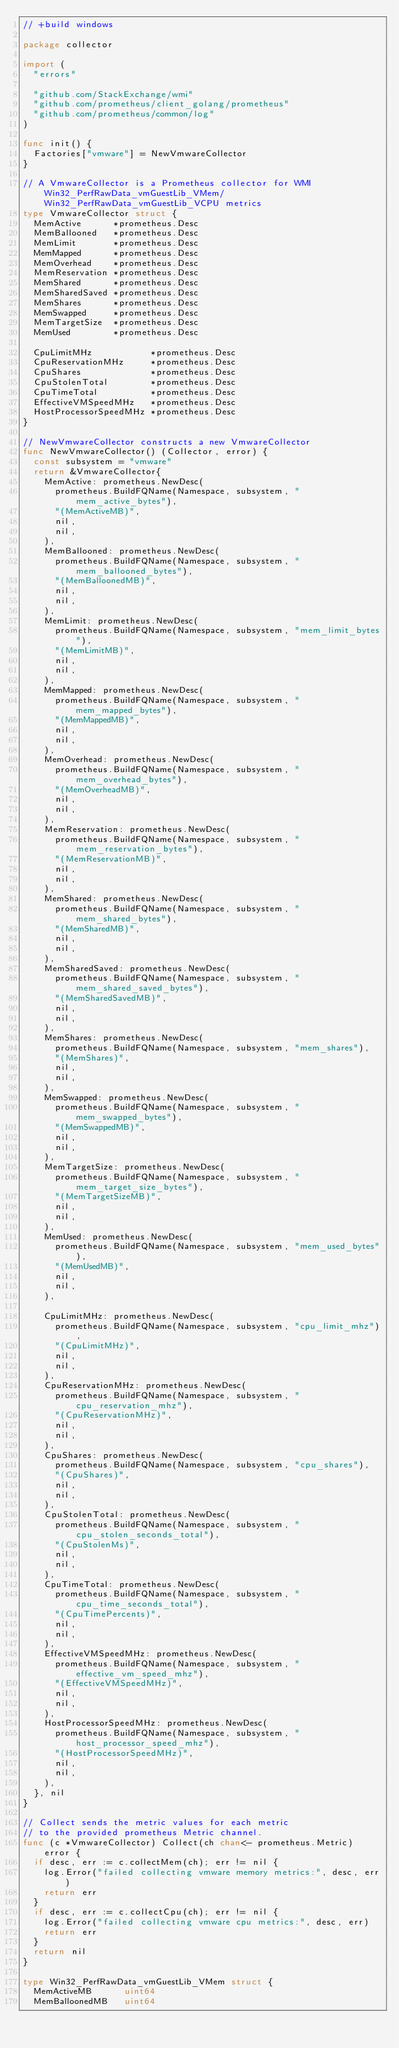<code> <loc_0><loc_0><loc_500><loc_500><_Go_>// +build windows

package collector

import (
	"errors"

	"github.com/StackExchange/wmi"
	"github.com/prometheus/client_golang/prometheus"
	"github.com/prometheus/common/log"
)

func init() {
	Factories["vmware"] = NewVmwareCollector
}

// A VmwareCollector is a Prometheus collector for WMI Win32_PerfRawData_vmGuestLib_VMem/Win32_PerfRawData_vmGuestLib_VCPU metrics
type VmwareCollector struct {
	MemActive      *prometheus.Desc
	MemBallooned   *prometheus.Desc
	MemLimit       *prometheus.Desc
	MemMapped      *prometheus.Desc
	MemOverhead    *prometheus.Desc
	MemReservation *prometheus.Desc
	MemShared      *prometheus.Desc
	MemSharedSaved *prometheus.Desc
	MemShares      *prometheus.Desc
	MemSwapped     *prometheus.Desc
	MemTargetSize  *prometheus.Desc
	MemUsed        *prometheus.Desc

	CpuLimitMHz           *prometheus.Desc
	CpuReservationMHz     *prometheus.Desc
	CpuShares             *prometheus.Desc
	CpuStolenTotal        *prometheus.Desc
	CpuTimeTotal          *prometheus.Desc
	EffectiveVMSpeedMHz   *prometheus.Desc
	HostProcessorSpeedMHz *prometheus.Desc
}

// NewVmwareCollector constructs a new VmwareCollector
func NewVmwareCollector() (Collector, error) {
	const subsystem = "vmware"
	return &VmwareCollector{
		MemActive: prometheus.NewDesc(
			prometheus.BuildFQName(Namespace, subsystem, "mem_active_bytes"),
			"(MemActiveMB)",
			nil,
			nil,
		),
		MemBallooned: prometheus.NewDesc(
			prometheus.BuildFQName(Namespace, subsystem, "mem_ballooned_bytes"),
			"(MemBalloonedMB)",
			nil,
			nil,
		),
		MemLimit: prometheus.NewDesc(
			prometheus.BuildFQName(Namespace, subsystem, "mem_limit_bytes"),
			"(MemLimitMB)",
			nil,
			nil,
		),
		MemMapped: prometheus.NewDesc(
			prometheus.BuildFQName(Namespace, subsystem, "mem_mapped_bytes"),
			"(MemMappedMB)",
			nil,
			nil,
		),
		MemOverhead: prometheus.NewDesc(
			prometheus.BuildFQName(Namespace, subsystem, "mem_overhead_bytes"),
			"(MemOverheadMB)",
			nil,
			nil,
		),
		MemReservation: prometheus.NewDesc(
			prometheus.BuildFQName(Namespace, subsystem, "mem_reservation_bytes"),
			"(MemReservationMB)",
			nil,
			nil,
		),
		MemShared: prometheus.NewDesc(
			prometheus.BuildFQName(Namespace, subsystem, "mem_shared_bytes"),
			"(MemSharedMB)",
			nil,
			nil,
		),
		MemSharedSaved: prometheus.NewDesc(
			prometheus.BuildFQName(Namespace, subsystem, "mem_shared_saved_bytes"),
			"(MemSharedSavedMB)",
			nil,
			nil,
		),
		MemShares: prometheus.NewDesc(
			prometheus.BuildFQName(Namespace, subsystem, "mem_shares"),
			"(MemShares)",
			nil,
			nil,
		),
		MemSwapped: prometheus.NewDesc(
			prometheus.BuildFQName(Namespace, subsystem, "mem_swapped_bytes"),
			"(MemSwappedMB)",
			nil,
			nil,
		),
		MemTargetSize: prometheus.NewDesc(
			prometheus.BuildFQName(Namespace, subsystem, "mem_target_size_bytes"),
			"(MemTargetSizeMB)",
			nil,
			nil,
		),
		MemUsed: prometheus.NewDesc(
			prometheus.BuildFQName(Namespace, subsystem, "mem_used_bytes"),
			"(MemUsedMB)",
			nil,
			nil,
		),

		CpuLimitMHz: prometheus.NewDesc(
			prometheus.BuildFQName(Namespace, subsystem, "cpu_limit_mhz"),
			"(CpuLimitMHz)",
			nil,
			nil,
		),
		CpuReservationMHz: prometheus.NewDesc(
			prometheus.BuildFQName(Namespace, subsystem, "cpu_reservation_mhz"),
			"(CpuReservationMHz)",
			nil,
			nil,
		),
		CpuShares: prometheus.NewDesc(
			prometheus.BuildFQName(Namespace, subsystem, "cpu_shares"),
			"(CpuShares)",
			nil,
			nil,
		),
		CpuStolenTotal: prometheus.NewDesc(
			prometheus.BuildFQName(Namespace, subsystem, "cpu_stolen_seconds_total"),
			"(CpuStolenMs)",
			nil,
			nil,
		),
		CpuTimeTotal: prometheus.NewDesc(
			prometheus.BuildFQName(Namespace, subsystem, "cpu_time_seconds_total"),
			"(CpuTimePercents)",
			nil,
			nil,
		),
		EffectiveVMSpeedMHz: prometheus.NewDesc(
			prometheus.BuildFQName(Namespace, subsystem, "effective_vm_speed_mhz"),
			"(EffectiveVMSpeedMHz)",
			nil,
			nil,
		),
		HostProcessorSpeedMHz: prometheus.NewDesc(
			prometheus.BuildFQName(Namespace, subsystem, "host_processor_speed_mhz"),
			"(HostProcessorSpeedMHz)",
			nil,
			nil,
		),
	}, nil
}

// Collect sends the metric values for each metric
// to the provided prometheus Metric channel.
func (c *VmwareCollector) Collect(ch chan<- prometheus.Metric) error {
	if desc, err := c.collectMem(ch); err != nil {
		log.Error("failed collecting vmware memory metrics:", desc, err)
		return err
	}
	if desc, err := c.collectCpu(ch); err != nil {
		log.Error("failed collecting vmware cpu metrics:", desc, err)
		return err
	}
	return nil
}

type Win32_PerfRawData_vmGuestLib_VMem struct {
	MemActiveMB      uint64
	MemBalloonedMB   uint64</code> 